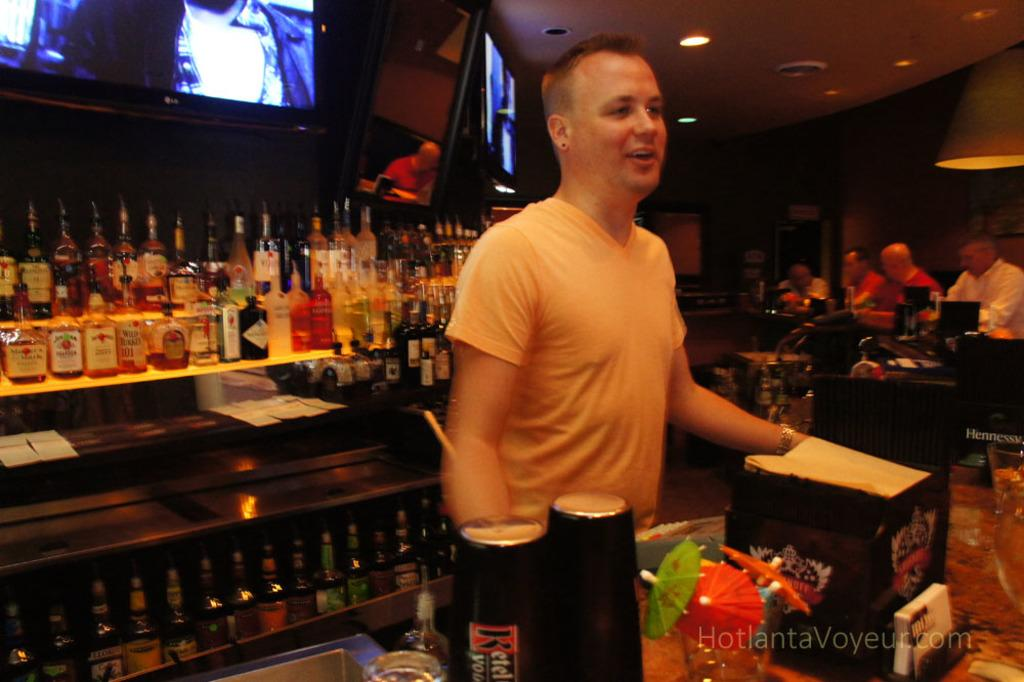<image>
Create a compact narrative representing the image presented. A picture that has a "hotlantavoyeur.com" on it. 